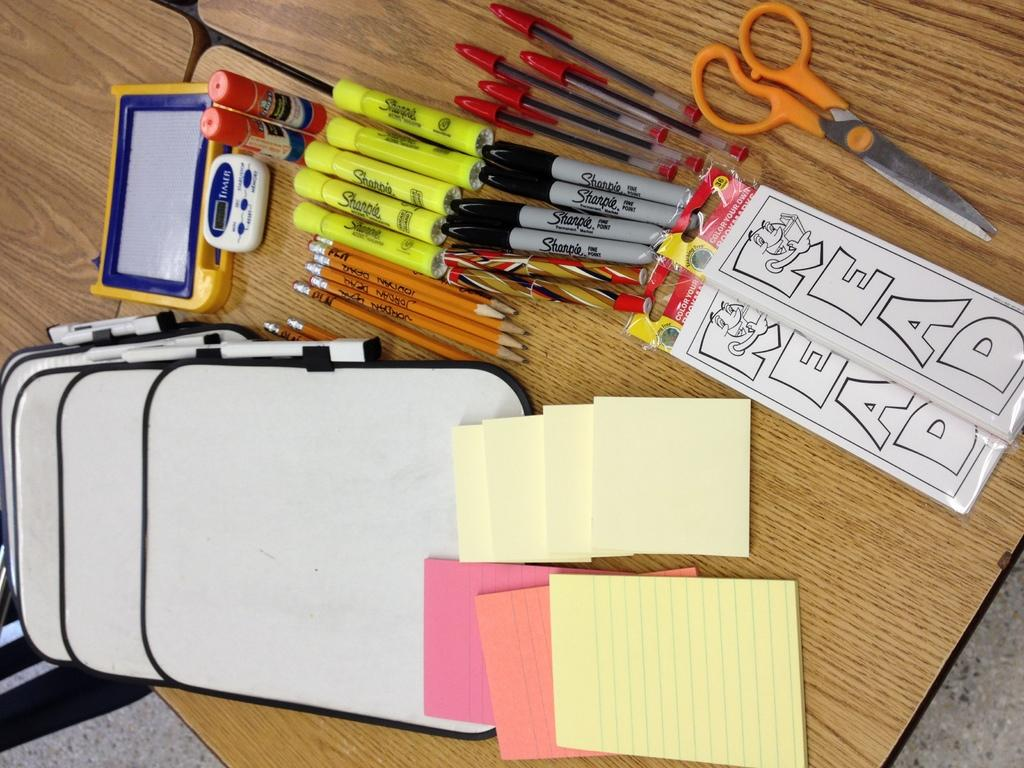Provide a one-sentence caption for the provided image. Various school supplies with the word READ on one supply. 